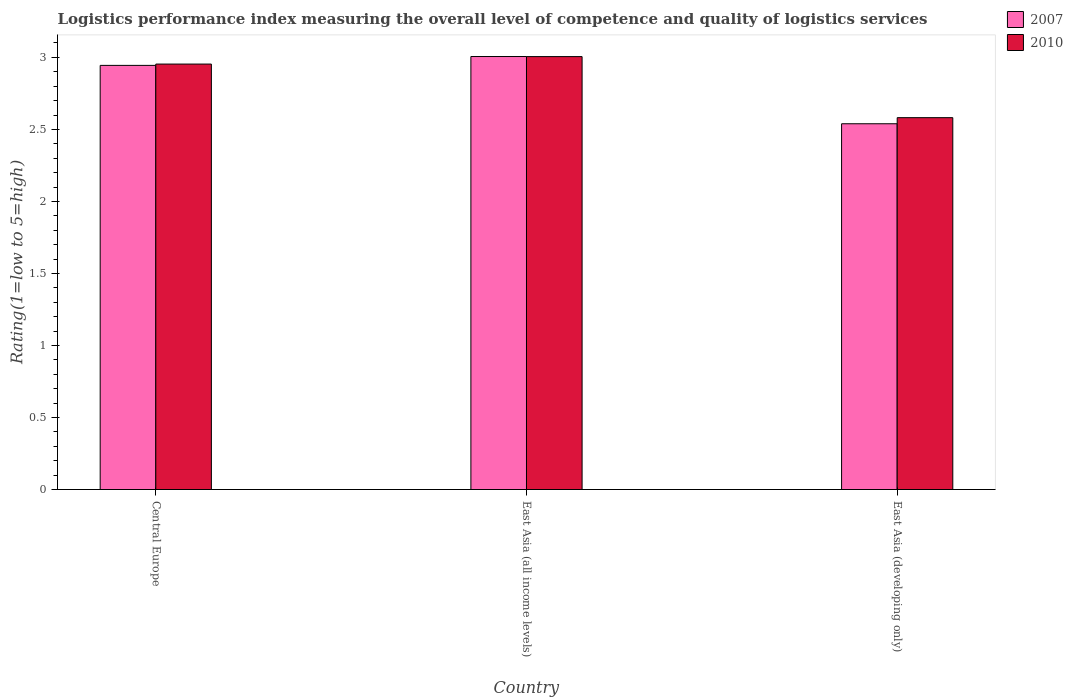How many different coloured bars are there?
Your answer should be very brief. 2. How many groups of bars are there?
Keep it short and to the point. 3. Are the number of bars on each tick of the X-axis equal?
Provide a succinct answer. Yes. How many bars are there on the 2nd tick from the right?
Offer a terse response. 2. What is the label of the 3rd group of bars from the left?
Provide a succinct answer. East Asia (developing only). In how many cases, is the number of bars for a given country not equal to the number of legend labels?
Ensure brevity in your answer.  0. What is the Logistic performance index in 2010 in East Asia (all income levels)?
Keep it short and to the point. 3.01. Across all countries, what is the maximum Logistic performance index in 2007?
Make the answer very short. 3.01. Across all countries, what is the minimum Logistic performance index in 2010?
Your response must be concise. 2.58. In which country was the Logistic performance index in 2010 maximum?
Give a very brief answer. East Asia (all income levels). In which country was the Logistic performance index in 2010 minimum?
Your answer should be compact. East Asia (developing only). What is the total Logistic performance index in 2010 in the graph?
Provide a short and direct response. 8.54. What is the difference between the Logistic performance index in 2010 in East Asia (all income levels) and that in East Asia (developing only)?
Your answer should be compact. 0.42. What is the difference between the Logistic performance index in 2007 in East Asia (all income levels) and the Logistic performance index in 2010 in Central Europe?
Ensure brevity in your answer.  0.05. What is the average Logistic performance index in 2007 per country?
Your response must be concise. 2.83. What is the difference between the Logistic performance index of/in 2007 and Logistic performance index of/in 2010 in East Asia (all income levels)?
Provide a short and direct response. 0. What is the ratio of the Logistic performance index in 2007 in Central Europe to that in East Asia (developing only)?
Your answer should be very brief. 1.16. What is the difference between the highest and the second highest Logistic performance index in 2007?
Keep it short and to the point. -0.41. What is the difference between the highest and the lowest Logistic performance index in 2007?
Give a very brief answer. 0.47. Is the sum of the Logistic performance index in 2010 in Central Europe and East Asia (all income levels) greater than the maximum Logistic performance index in 2007 across all countries?
Make the answer very short. Yes. What does the 1st bar from the left in East Asia (all income levels) represents?
Your answer should be very brief. 2007. How many bars are there?
Keep it short and to the point. 6. What is the difference between two consecutive major ticks on the Y-axis?
Your answer should be very brief. 0.5. Are the values on the major ticks of Y-axis written in scientific E-notation?
Keep it short and to the point. No. Where does the legend appear in the graph?
Ensure brevity in your answer.  Top right. How many legend labels are there?
Your answer should be very brief. 2. How are the legend labels stacked?
Your answer should be very brief. Vertical. What is the title of the graph?
Offer a terse response. Logistics performance index measuring the overall level of competence and quality of logistics services. Does "2005" appear as one of the legend labels in the graph?
Give a very brief answer. No. What is the label or title of the X-axis?
Provide a short and direct response. Country. What is the label or title of the Y-axis?
Provide a short and direct response. Rating(1=low to 5=high). What is the Rating(1=low to 5=high) of 2007 in Central Europe?
Keep it short and to the point. 2.94. What is the Rating(1=low to 5=high) of 2010 in Central Europe?
Provide a succinct answer. 2.95. What is the Rating(1=low to 5=high) of 2007 in East Asia (all income levels)?
Your answer should be very brief. 3.01. What is the Rating(1=low to 5=high) in 2010 in East Asia (all income levels)?
Give a very brief answer. 3.01. What is the Rating(1=low to 5=high) in 2007 in East Asia (developing only)?
Offer a terse response. 2.54. What is the Rating(1=low to 5=high) of 2010 in East Asia (developing only)?
Provide a succinct answer. 2.58. Across all countries, what is the maximum Rating(1=low to 5=high) in 2007?
Ensure brevity in your answer.  3.01. Across all countries, what is the maximum Rating(1=low to 5=high) of 2010?
Keep it short and to the point. 3.01. Across all countries, what is the minimum Rating(1=low to 5=high) of 2007?
Offer a terse response. 2.54. Across all countries, what is the minimum Rating(1=low to 5=high) of 2010?
Your response must be concise. 2.58. What is the total Rating(1=low to 5=high) in 2007 in the graph?
Give a very brief answer. 8.49. What is the total Rating(1=low to 5=high) in 2010 in the graph?
Your answer should be compact. 8.54. What is the difference between the Rating(1=low to 5=high) in 2007 in Central Europe and that in East Asia (all income levels)?
Offer a very short reply. -0.06. What is the difference between the Rating(1=low to 5=high) in 2010 in Central Europe and that in East Asia (all income levels)?
Offer a terse response. -0.05. What is the difference between the Rating(1=low to 5=high) in 2007 in Central Europe and that in East Asia (developing only)?
Give a very brief answer. 0.41. What is the difference between the Rating(1=low to 5=high) in 2010 in Central Europe and that in East Asia (developing only)?
Offer a terse response. 0.37. What is the difference between the Rating(1=low to 5=high) of 2007 in East Asia (all income levels) and that in East Asia (developing only)?
Provide a short and direct response. 0.47. What is the difference between the Rating(1=low to 5=high) of 2010 in East Asia (all income levels) and that in East Asia (developing only)?
Your answer should be very brief. 0.42. What is the difference between the Rating(1=low to 5=high) of 2007 in Central Europe and the Rating(1=low to 5=high) of 2010 in East Asia (all income levels)?
Provide a succinct answer. -0.06. What is the difference between the Rating(1=low to 5=high) of 2007 in Central Europe and the Rating(1=low to 5=high) of 2010 in East Asia (developing only)?
Ensure brevity in your answer.  0.36. What is the difference between the Rating(1=low to 5=high) in 2007 in East Asia (all income levels) and the Rating(1=low to 5=high) in 2010 in East Asia (developing only)?
Offer a terse response. 0.42. What is the average Rating(1=low to 5=high) of 2007 per country?
Your answer should be very brief. 2.83. What is the average Rating(1=low to 5=high) in 2010 per country?
Offer a terse response. 2.85. What is the difference between the Rating(1=low to 5=high) in 2007 and Rating(1=low to 5=high) in 2010 in Central Europe?
Offer a terse response. -0.01. What is the difference between the Rating(1=low to 5=high) of 2007 and Rating(1=low to 5=high) of 2010 in East Asia (developing only)?
Ensure brevity in your answer.  -0.04. What is the ratio of the Rating(1=low to 5=high) in 2007 in Central Europe to that in East Asia (all income levels)?
Ensure brevity in your answer.  0.98. What is the ratio of the Rating(1=low to 5=high) in 2010 in Central Europe to that in East Asia (all income levels)?
Offer a very short reply. 0.98. What is the ratio of the Rating(1=low to 5=high) in 2007 in Central Europe to that in East Asia (developing only)?
Ensure brevity in your answer.  1.16. What is the ratio of the Rating(1=low to 5=high) in 2010 in Central Europe to that in East Asia (developing only)?
Your response must be concise. 1.14. What is the ratio of the Rating(1=low to 5=high) of 2007 in East Asia (all income levels) to that in East Asia (developing only)?
Give a very brief answer. 1.18. What is the ratio of the Rating(1=low to 5=high) in 2010 in East Asia (all income levels) to that in East Asia (developing only)?
Make the answer very short. 1.16. What is the difference between the highest and the second highest Rating(1=low to 5=high) of 2007?
Keep it short and to the point. 0.06. What is the difference between the highest and the second highest Rating(1=low to 5=high) in 2010?
Offer a terse response. 0.05. What is the difference between the highest and the lowest Rating(1=low to 5=high) of 2007?
Your response must be concise. 0.47. What is the difference between the highest and the lowest Rating(1=low to 5=high) in 2010?
Make the answer very short. 0.42. 